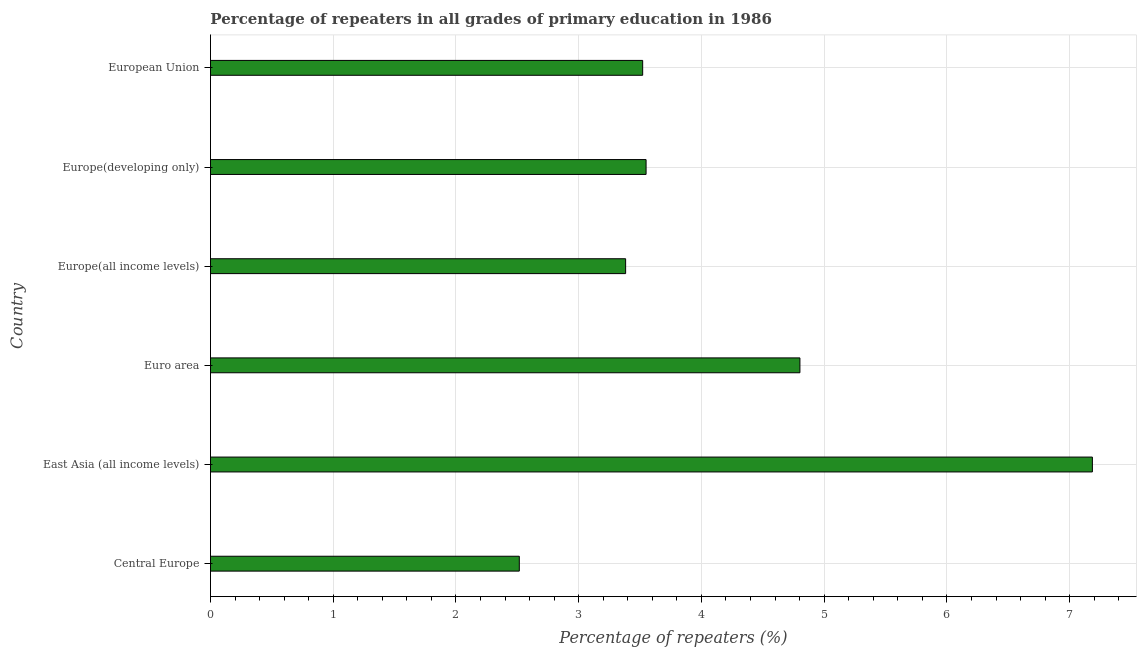Does the graph contain any zero values?
Provide a succinct answer. No. What is the title of the graph?
Your answer should be compact. Percentage of repeaters in all grades of primary education in 1986. What is the label or title of the X-axis?
Your answer should be very brief. Percentage of repeaters (%). What is the percentage of repeaters in primary education in Europe(all income levels)?
Provide a succinct answer. 3.38. Across all countries, what is the maximum percentage of repeaters in primary education?
Your response must be concise. 7.19. Across all countries, what is the minimum percentage of repeaters in primary education?
Your answer should be very brief. 2.52. In which country was the percentage of repeaters in primary education maximum?
Keep it short and to the point. East Asia (all income levels). In which country was the percentage of repeaters in primary education minimum?
Keep it short and to the point. Central Europe. What is the sum of the percentage of repeaters in primary education?
Provide a succinct answer. 24.96. What is the difference between the percentage of repeaters in primary education in East Asia (all income levels) and Euro area?
Your answer should be compact. 2.38. What is the average percentage of repeaters in primary education per country?
Your answer should be compact. 4.16. What is the median percentage of repeaters in primary education?
Your answer should be very brief. 3.54. In how many countries, is the percentage of repeaters in primary education greater than 1.8 %?
Your answer should be very brief. 6. What is the ratio of the percentage of repeaters in primary education in Europe(all income levels) to that in Europe(developing only)?
Make the answer very short. 0.95. What is the difference between the highest and the second highest percentage of repeaters in primary education?
Your answer should be very brief. 2.38. What is the difference between the highest and the lowest percentage of repeaters in primary education?
Provide a succinct answer. 4.67. How many bars are there?
Give a very brief answer. 6. What is the difference between two consecutive major ticks on the X-axis?
Keep it short and to the point. 1. What is the Percentage of repeaters (%) of Central Europe?
Offer a very short reply. 2.52. What is the Percentage of repeaters (%) in East Asia (all income levels)?
Your response must be concise. 7.19. What is the Percentage of repeaters (%) of Euro area?
Offer a very short reply. 4.8. What is the Percentage of repeaters (%) of Europe(all income levels)?
Ensure brevity in your answer.  3.38. What is the Percentage of repeaters (%) of Europe(developing only)?
Provide a short and direct response. 3.55. What is the Percentage of repeaters (%) in European Union?
Provide a short and direct response. 3.52. What is the difference between the Percentage of repeaters (%) in Central Europe and East Asia (all income levels)?
Ensure brevity in your answer.  -4.67. What is the difference between the Percentage of repeaters (%) in Central Europe and Euro area?
Give a very brief answer. -2.29. What is the difference between the Percentage of repeaters (%) in Central Europe and Europe(all income levels)?
Your answer should be very brief. -0.87. What is the difference between the Percentage of repeaters (%) in Central Europe and Europe(developing only)?
Offer a terse response. -1.03. What is the difference between the Percentage of repeaters (%) in Central Europe and European Union?
Provide a succinct answer. -1.01. What is the difference between the Percentage of repeaters (%) in East Asia (all income levels) and Euro area?
Make the answer very short. 2.38. What is the difference between the Percentage of repeaters (%) in East Asia (all income levels) and Europe(all income levels)?
Your answer should be very brief. 3.8. What is the difference between the Percentage of repeaters (%) in East Asia (all income levels) and Europe(developing only)?
Your response must be concise. 3.64. What is the difference between the Percentage of repeaters (%) in East Asia (all income levels) and European Union?
Give a very brief answer. 3.66. What is the difference between the Percentage of repeaters (%) in Euro area and Europe(all income levels)?
Provide a succinct answer. 1.42. What is the difference between the Percentage of repeaters (%) in Euro area and Europe(developing only)?
Make the answer very short. 1.25. What is the difference between the Percentage of repeaters (%) in Euro area and European Union?
Make the answer very short. 1.28. What is the difference between the Percentage of repeaters (%) in Europe(all income levels) and Europe(developing only)?
Provide a succinct answer. -0.17. What is the difference between the Percentage of repeaters (%) in Europe(all income levels) and European Union?
Give a very brief answer. -0.14. What is the difference between the Percentage of repeaters (%) in Europe(developing only) and European Union?
Your answer should be compact. 0.03. What is the ratio of the Percentage of repeaters (%) in Central Europe to that in East Asia (all income levels)?
Your answer should be compact. 0.35. What is the ratio of the Percentage of repeaters (%) in Central Europe to that in Euro area?
Ensure brevity in your answer.  0.52. What is the ratio of the Percentage of repeaters (%) in Central Europe to that in Europe(all income levels)?
Ensure brevity in your answer.  0.74. What is the ratio of the Percentage of repeaters (%) in Central Europe to that in Europe(developing only)?
Keep it short and to the point. 0.71. What is the ratio of the Percentage of repeaters (%) in Central Europe to that in European Union?
Ensure brevity in your answer.  0.71. What is the ratio of the Percentage of repeaters (%) in East Asia (all income levels) to that in Euro area?
Your response must be concise. 1.5. What is the ratio of the Percentage of repeaters (%) in East Asia (all income levels) to that in Europe(all income levels)?
Your answer should be compact. 2.12. What is the ratio of the Percentage of repeaters (%) in East Asia (all income levels) to that in Europe(developing only)?
Your response must be concise. 2.02. What is the ratio of the Percentage of repeaters (%) in East Asia (all income levels) to that in European Union?
Give a very brief answer. 2.04. What is the ratio of the Percentage of repeaters (%) in Euro area to that in Europe(all income levels)?
Keep it short and to the point. 1.42. What is the ratio of the Percentage of repeaters (%) in Euro area to that in Europe(developing only)?
Make the answer very short. 1.35. What is the ratio of the Percentage of repeaters (%) in Euro area to that in European Union?
Offer a very short reply. 1.36. What is the ratio of the Percentage of repeaters (%) in Europe(all income levels) to that in Europe(developing only)?
Provide a short and direct response. 0.95. 